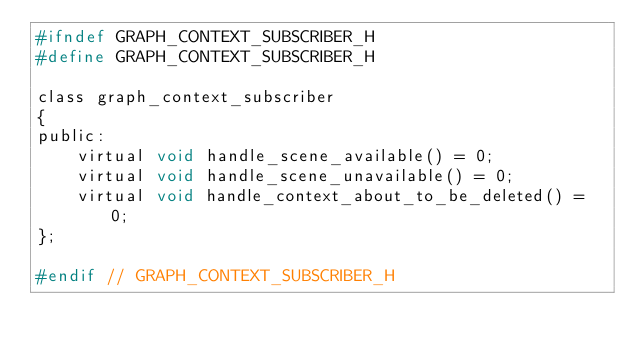<code> <loc_0><loc_0><loc_500><loc_500><_C_>#ifndef GRAPH_CONTEXT_SUBSCRIBER_H
#define GRAPH_CONTEXT_SUBSCRIBER_H

class graph_context_subscriber
{
public:
    virtual void handle_scene_available() = 0;
    virtual void handle_scene_unavailable() = 0;
    virtual void handle_context_about_to_be_deleted() = 0;
};

#endif // GRAPH_CONTEXT_SUBSCRIBER_H
</code> 